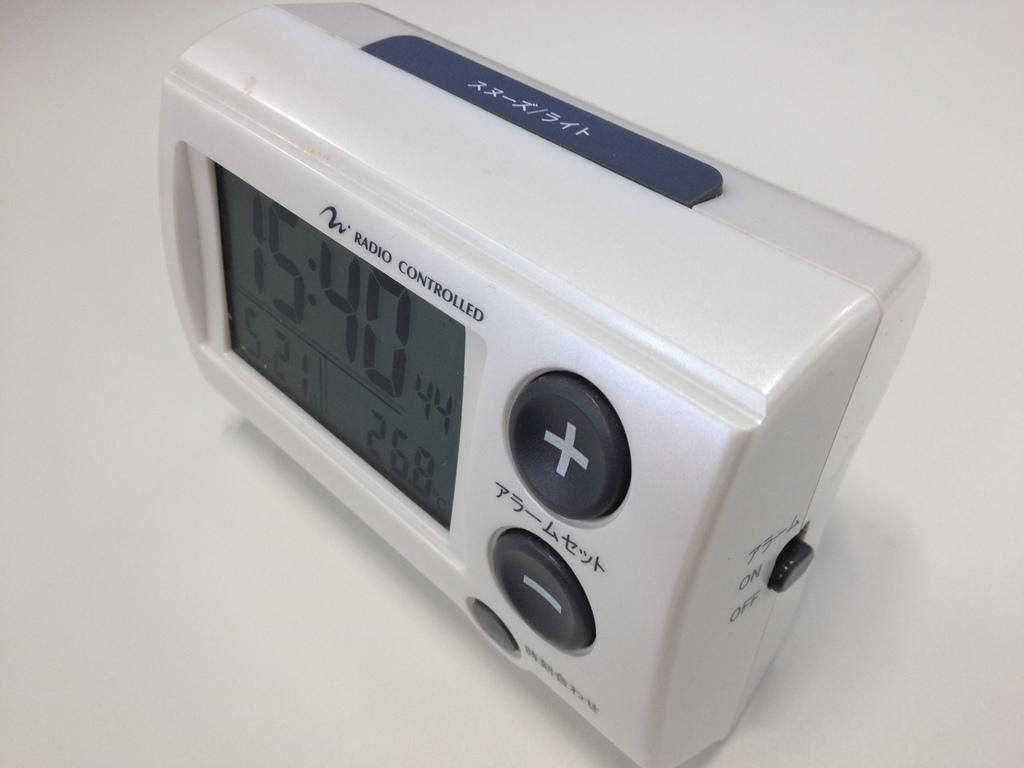<image>
Describe the image concisely. a radio controlled device has the numbers 15:40 on it 